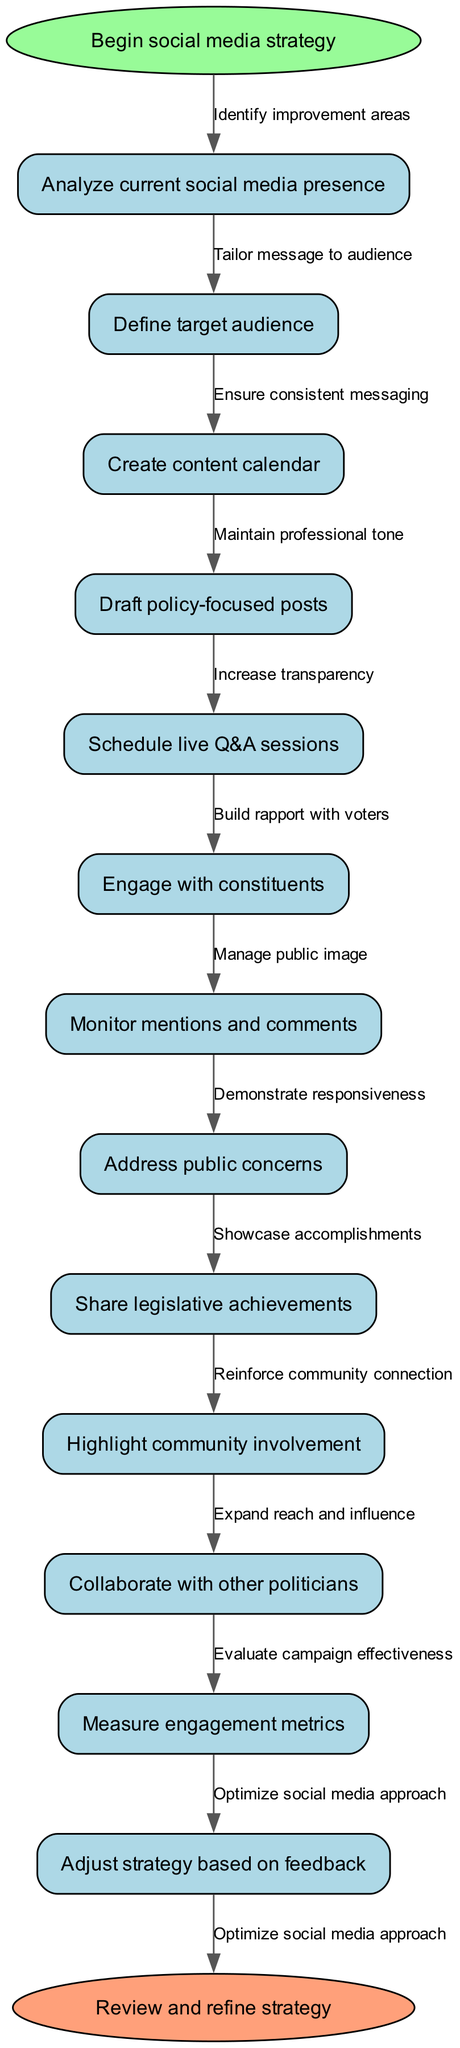What is the first action in the social media strategy? The diagram starts with the "Begin social media strategy" node, indicating that this is the first action to take.
Answer: Begin social media strategy How many main nodes are present in the flowchart? The flowchart lists 12 main nodes for actions taken in the social media strategy as seen in the diagram.
Answer: 12 What is the last action before reviewing the strategy? The final action before reaching the end node is "Adjust strategy based on feedback," which is the last main node leading to the review step.
Answer: Adjust strategy based on feedback What action follows "Define target audience"? According to the flowchart, the action that follows "Define target audience" is "Create content calendar," as they are connected in sequence.
Answer: Create content calendar Which nodes demonstrate community connection? Both "Highlight community involvement" and "Engage with constituents" emphasize community connection, showing a focus on engagement with the constituency.
Answer: Highlight community involvement, Engage with constituents How does the diagram indicate the importance of feedback? Feedback is emphasized through the "Adjust strategy based on feedback" action, showing that the strategy implementation requires iterative improvement based on responses and metrics.
Answer: Adjust strategy based on feedback What are the two actions illustrating engagement with voters? The actions showing engagement with voters are "Engage with constituents" and "Schedule live Q&A sessions," as both are focused on interaction and responsiveness to the public.
Answer: Engage with constituents, Schedule live Q&A sessions What role does “Measure engagement metrics” play in the strategy? “Measure engagement metrics” serves as a crucial step for evaluating how effective various actions are in achieving desired interactions with the target audience.
Answer: Evaluate campaign effectiveness Which node emphasizes the collaboration aspect among politicians? The node “Collaborate with other politicians” specifically highlights the strategy's focus on cooperative efforts with peers in the political landscape.
Answer: Collaborate with other politicians 